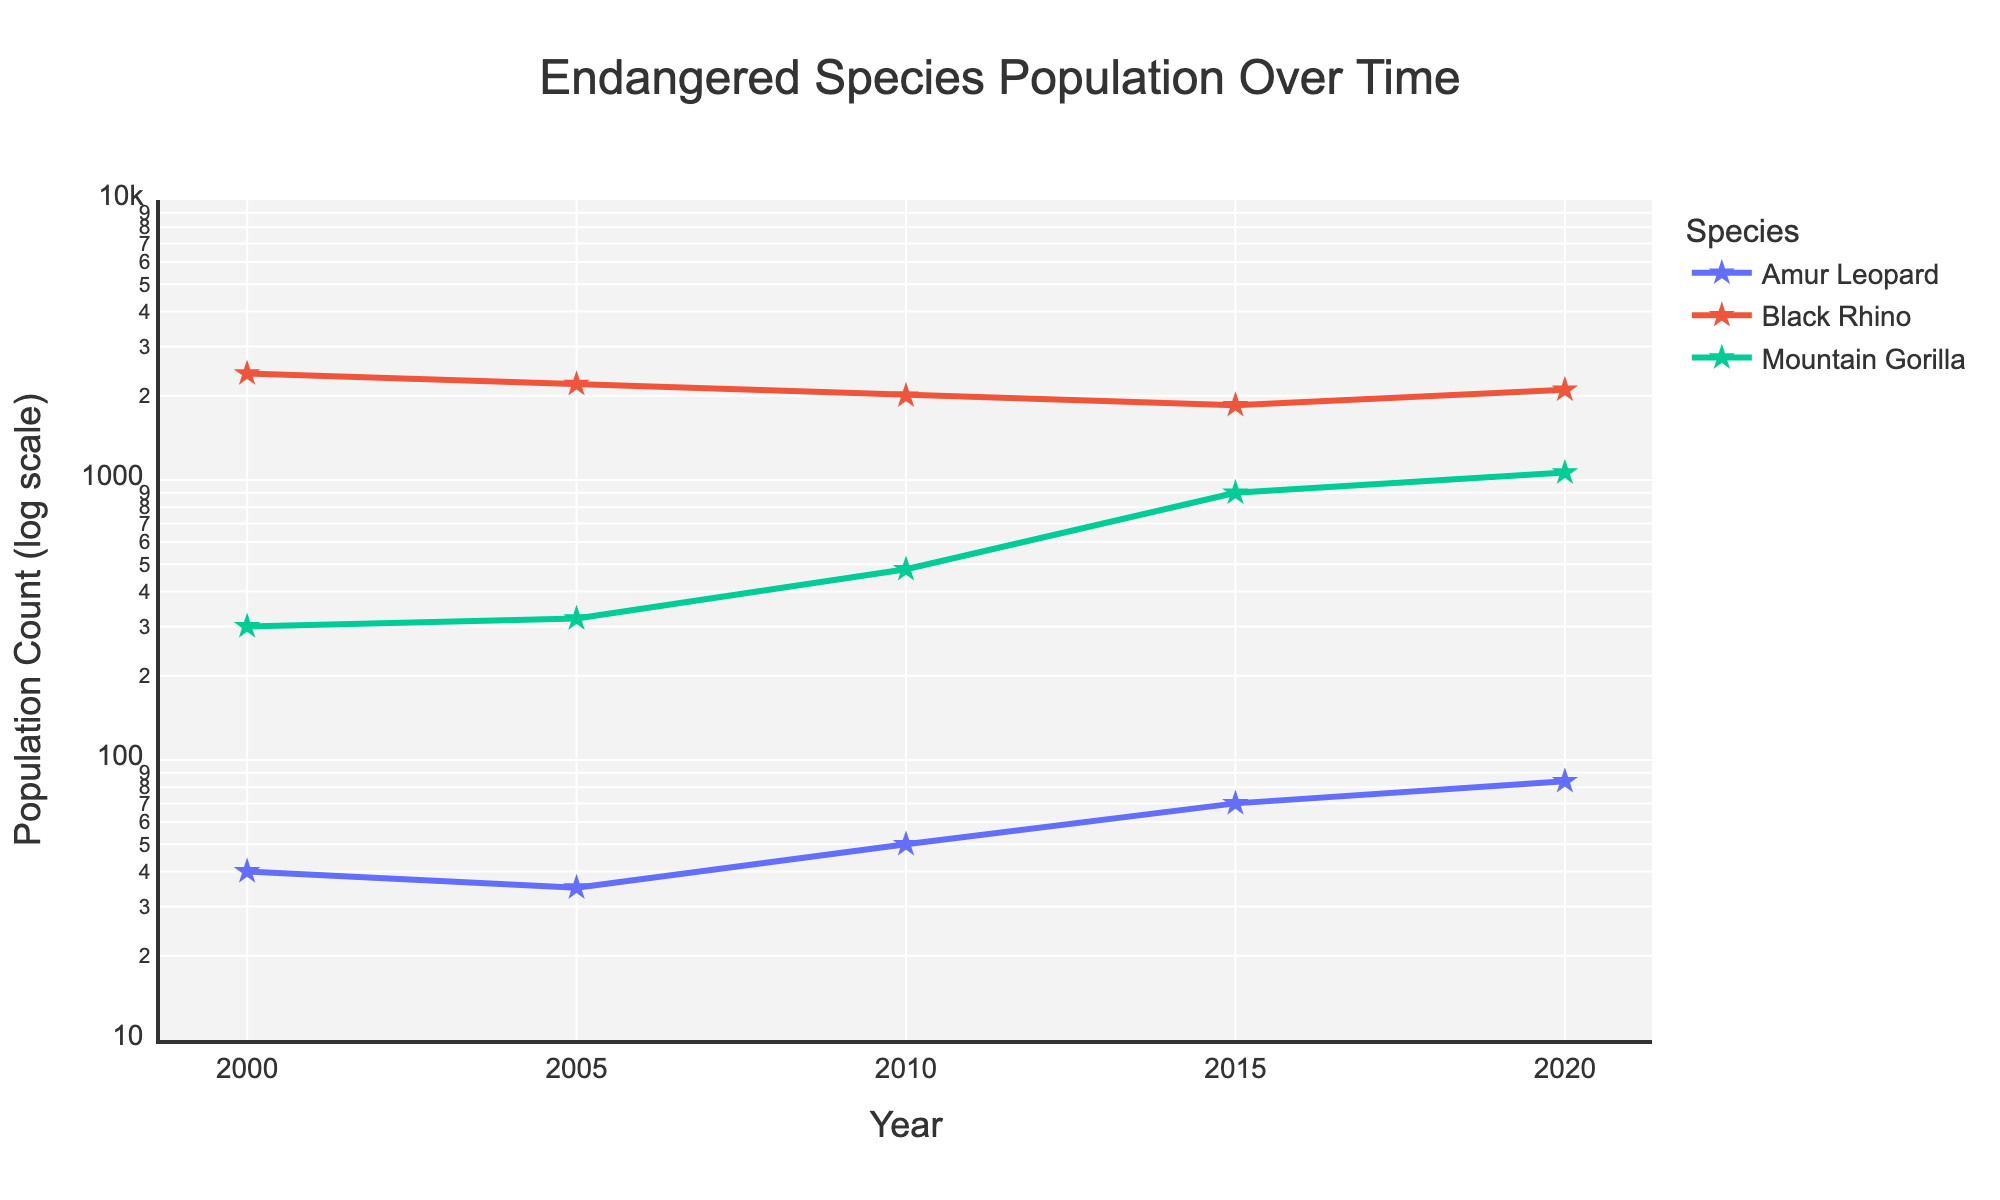what is the title of the plot? The title is usually located at the top center of the plot. It summarizes the main focus of the figure. Here, it reads "Endangered Species Population Over Time".
Answer: Endangered Species Population Over Time What are the labels for the x-axis and y-axis? Axis labels describe what each axis represents. Here, the x-axis label is "Year" and the y-axis label is "Population Count (log scale)".
Answer: Year, Population Count (log scale) How many species are tracked in the figure? Each trace in the figure represents a different species. By counting the unique lines with markers, we can see there are three species: Amur Leopard, Black Rhino, and Mountain Gorilla.
Answer: Three Which species had the highest population count in 2015? By looking at the year 2015 on the x-axis and checking the y-values for all species, the species with the highest y-value is the Mountain Gorilla with a population count of 900.
Answer: Mountain Gorilla What trend do you observe for the Amur Leopard from 2000 to 2020? Tracking the line for Amur Leopard from 2000 to 2020, we see that the population count increases over time from 40 to 84.
Answer: Increasing trend Which year showed the highest population count for the Mountain Gorilla? Reviewing the trend line for Mountain Gorilla, the highest population count occurs in 2020, with a value of 1063.
Answer: 2020 From 2005 to 2020, how did the population of the Black Rhino change? By checking the data points for Black Rhino from 2005 to 2020, the population count decreased from 2200 to 2100.
Answer: Decreased What is the population count range shown on the y-axis? The y-axis is in a log scale, ranging from 10^1 (10) to 10^4 (10000).
Answer: 10 to 10,000 Between which years did the Amur Leopard see the largest increase in population count? Checking the data points for Amur Leopard, the largest increase occurs between 2005 and 2010, where the population rises from 35 to 50.
Answer: 2005 to 2010 